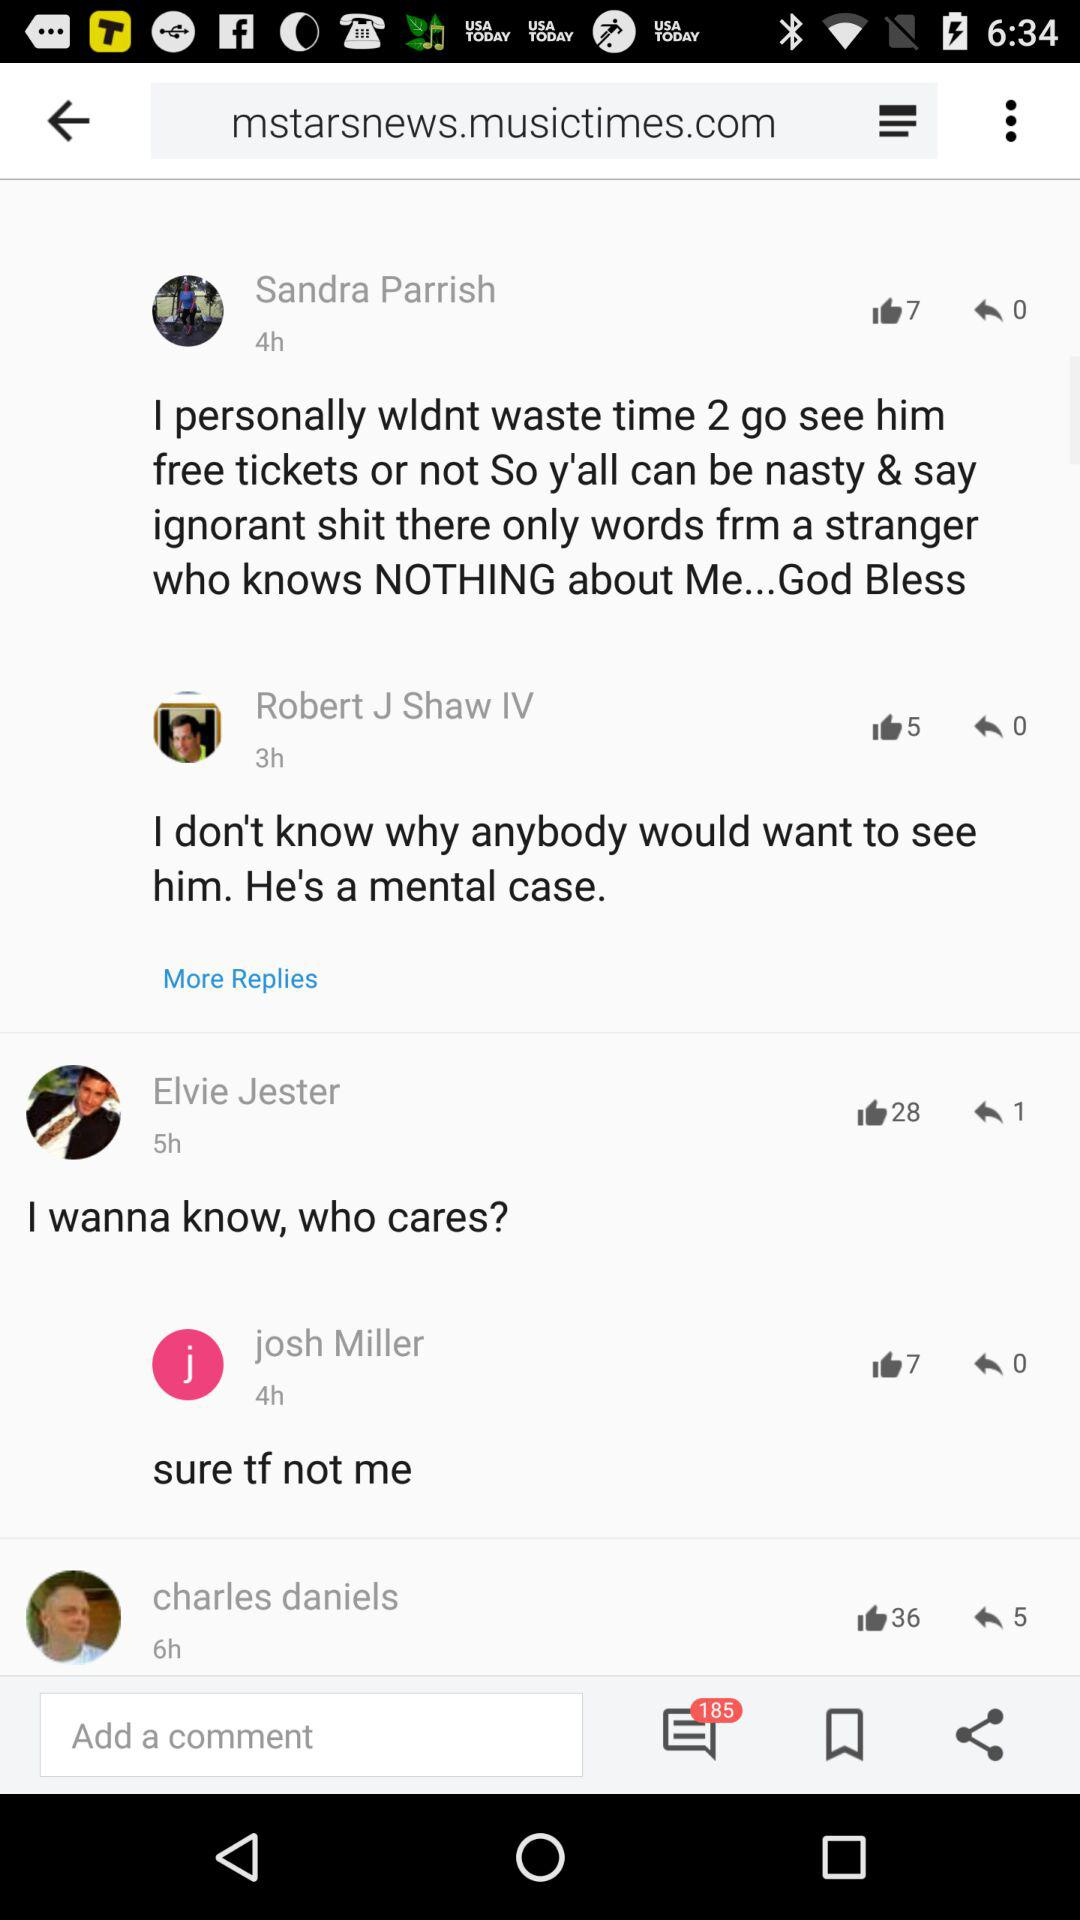At what time did Elvie Jester post? Elvie Jester posted 5 hours ago. 